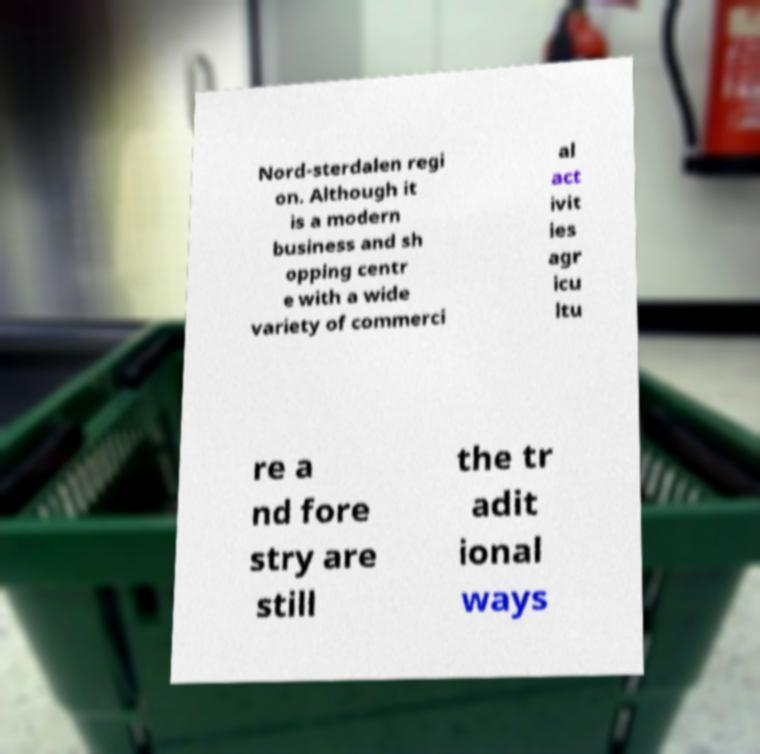Can you accurately transcribe the text from the provided image for me? Nord-sterdalen regi on. Although it is a modern business and sh opping centr e with a wide variety of commerci al act ivit ies agr icu ltu re a nd fore stry are still the tr adit ional ways 